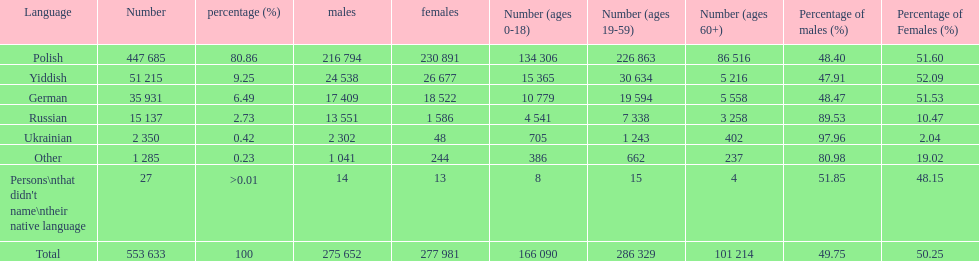What are all of the languages? Polish, Yiddish, German, Russian, Ukrainian, Other, Persons\nthat didn't name\ntheir native language. And how many people speak these languages? 447 685, 51 215, 35 931, 15 137, 2 350, 1 285, 27. Which language is used by most people? Polish. 